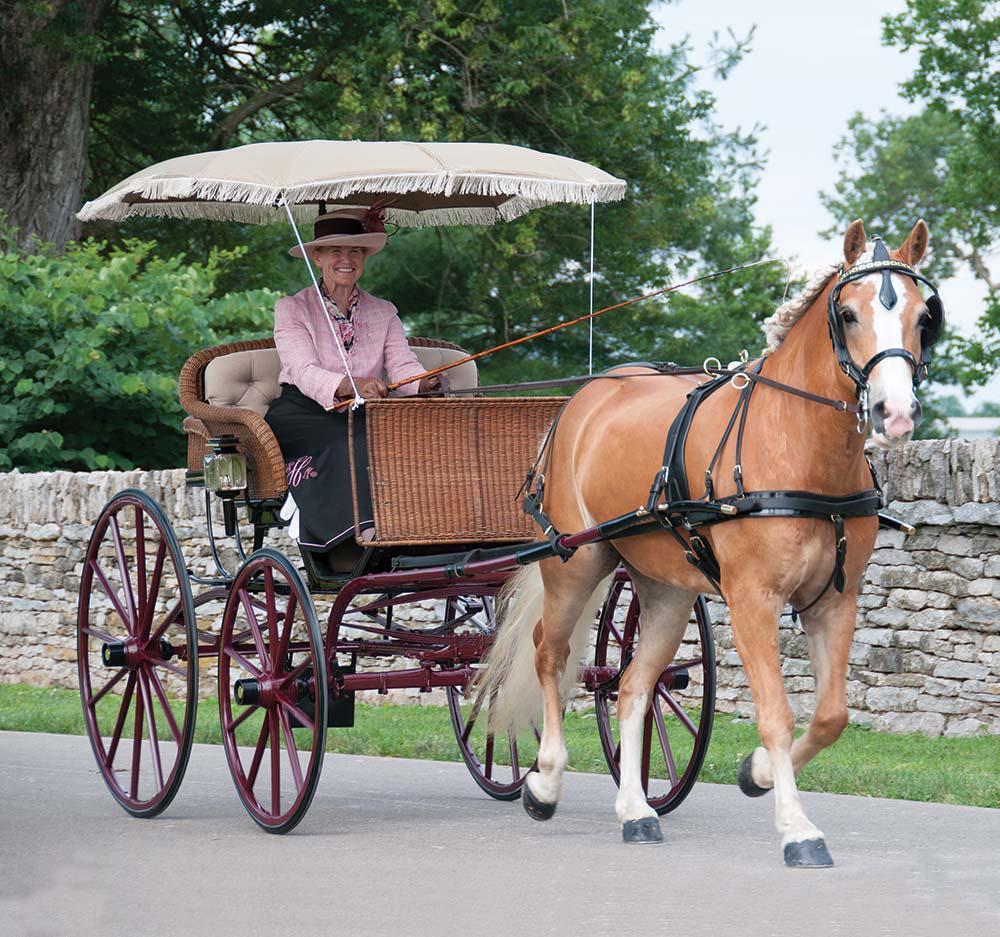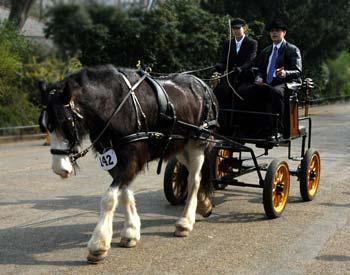The first image is the image on the left, the second image is the image on the right. Assess this claim about the two images: "Right image includes a wagon pulled by at least one tan Clydesdale horse". Correct or not? Answer yes or no. No. The first image is the image on the left, the second image is the image on the right. For the images displayed, is the sentence "There is one rider in the cart on the left" factually correct? Answer yes or no. Yes. 